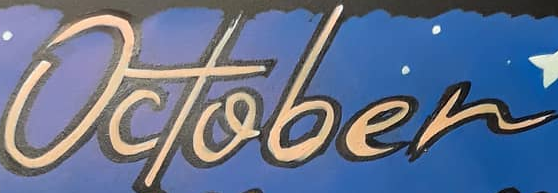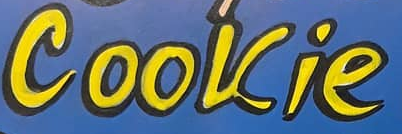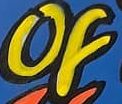What text is displayed in these images sequentially, separated by a semicolon? October; Cookie; of 